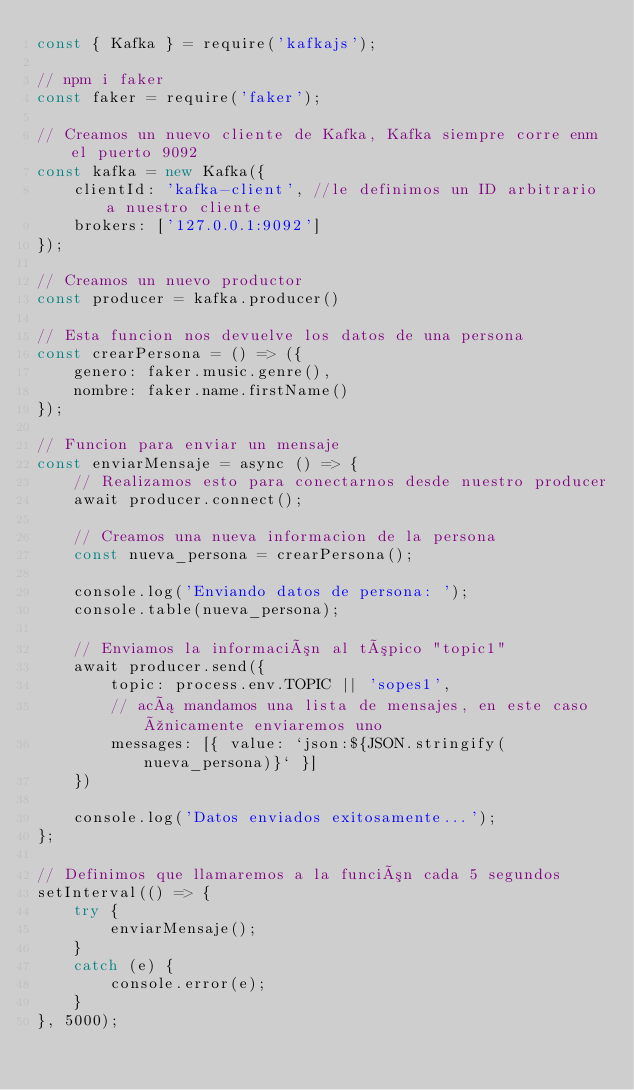<code> <loc_0><loc_0><loc_500><loc_500><_JavaScript_>const { Kafka } = require('kafkajs');

// npm i faker
const faker = require('faker');

// Creamos un nuevo cliente de Kafka, Kafka siempre corre enm el puerto 9092
const kafka = new Kafka({
    clientId: 'kafka-client', //le definimos un ID arbitrario a nuestro cliente
    brokers: ['127.0.0.1:9092']
});

// Creamos un nuevo productor
const producer = kafka.producer()

// Esta funcion nos devuelve los datos de una persona
const crearPersona = () => ({
    genero: faker.music.genre(),
    nombre: faker.name.firstName()
});

// Funcion para enviar un mensaje
const enviarMensaje = async () => {
    // Realizamos esto para conectarnos desde nuestro producer
    await producer.connect();

    // Creamos una nueva informacion de la persona
    const nueva_persona = crearPersona();

    console.log('Enviando datos de persona: ');
    console.table(nueva_persona);

    // Enviamos la información al tópico "topic1"
    await producer.send({
        topic: process.env.TOPIC || 'sopes1',
        // acá mandamos una lista de mensajes, en este caso únicamente enviaremos uno
        messages: [{ value: `json:${JSON.stringify(nueva_persona)}` }]
    })

    console.log('Datos enviados exitosamente...');
};

// Definimos que llamaremos a la función cada 5 segundos
setInterval(() => {
    try {
        enviarMensaje();
    }
    catch (e) {
        console.error(e);
    }
}, 5000);</code> 